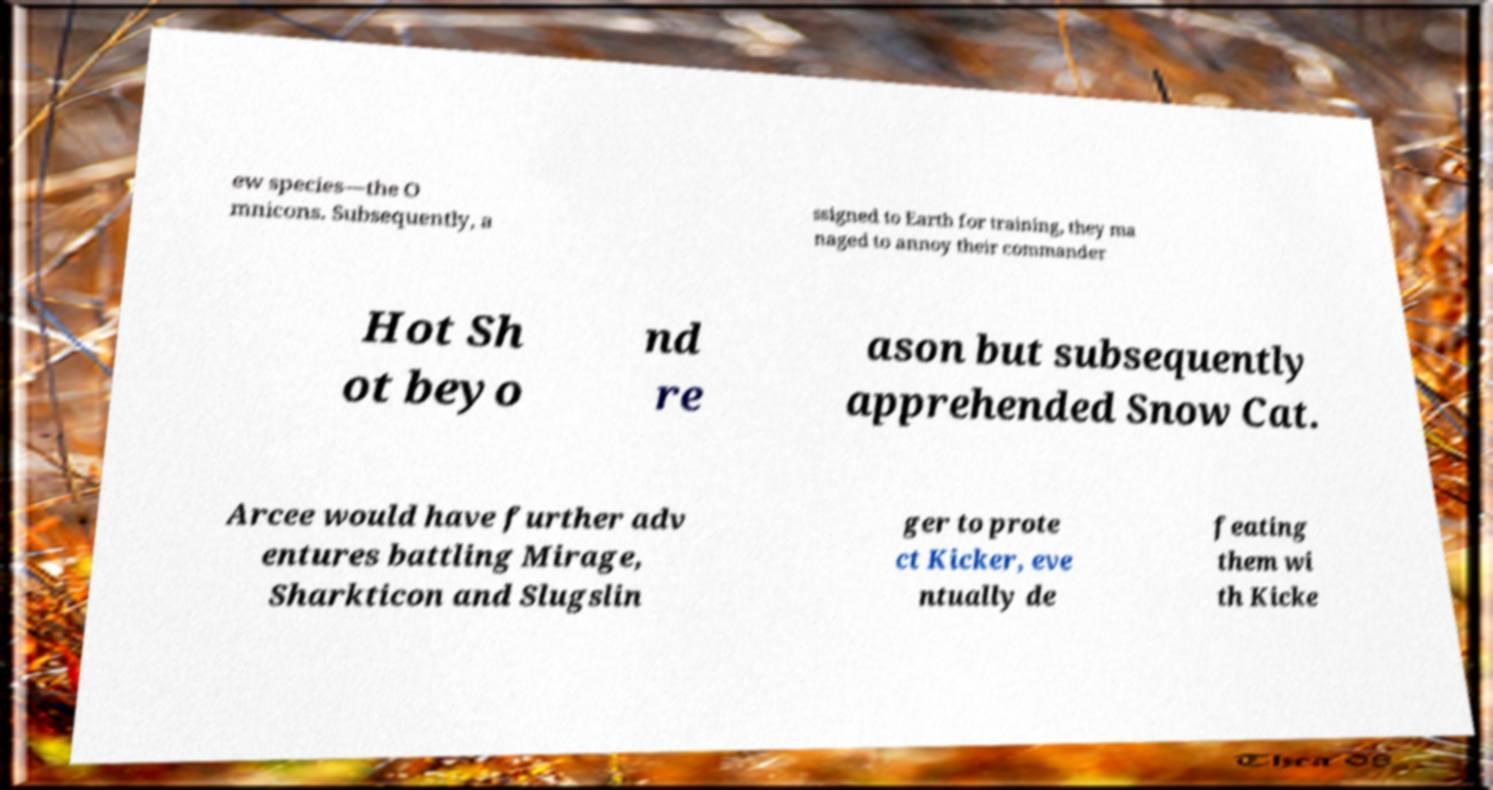I need the written content from this picture converted into text. Can you do that? ew species—the O mnicons. Subsequently, a ssigned to Earth for training, they ma naged to annoy their commander Hot Sh ot beyo nd re ason but subsequently apprehended Snow Cat. Arcee would have further adv entures battling Mirage, Sharkticon and Slugslin ger to prote ct Kicker, eve ntually de feating them wi th Kicke 